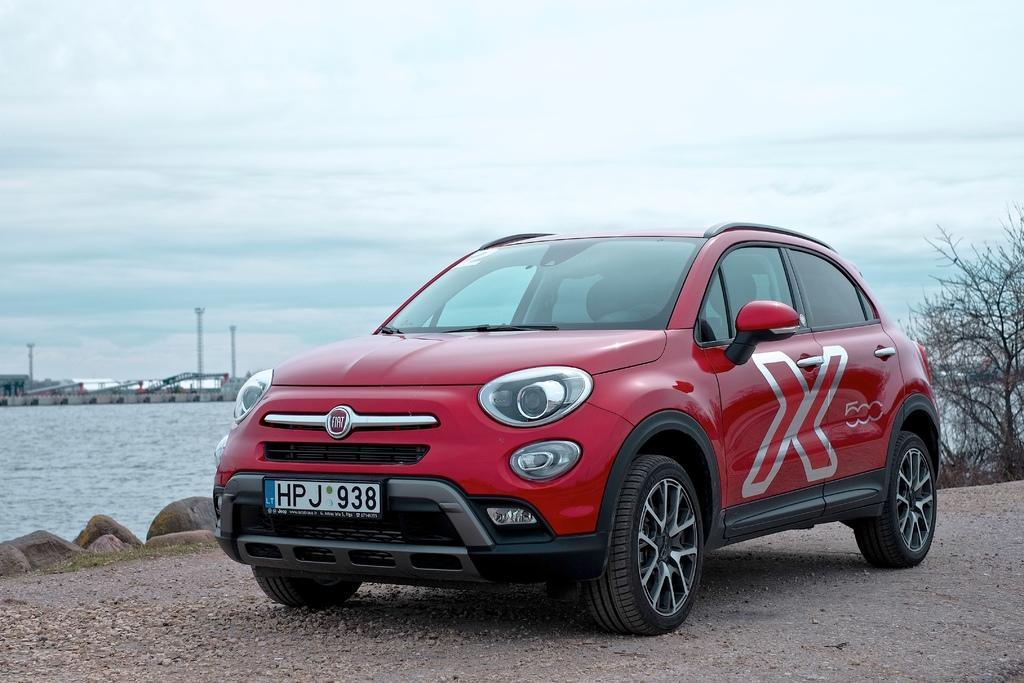Describe this image in one or two sentences. In the picture I can see a red color car on the ground. In the background I can see a tree, the water, poles and the sky. 